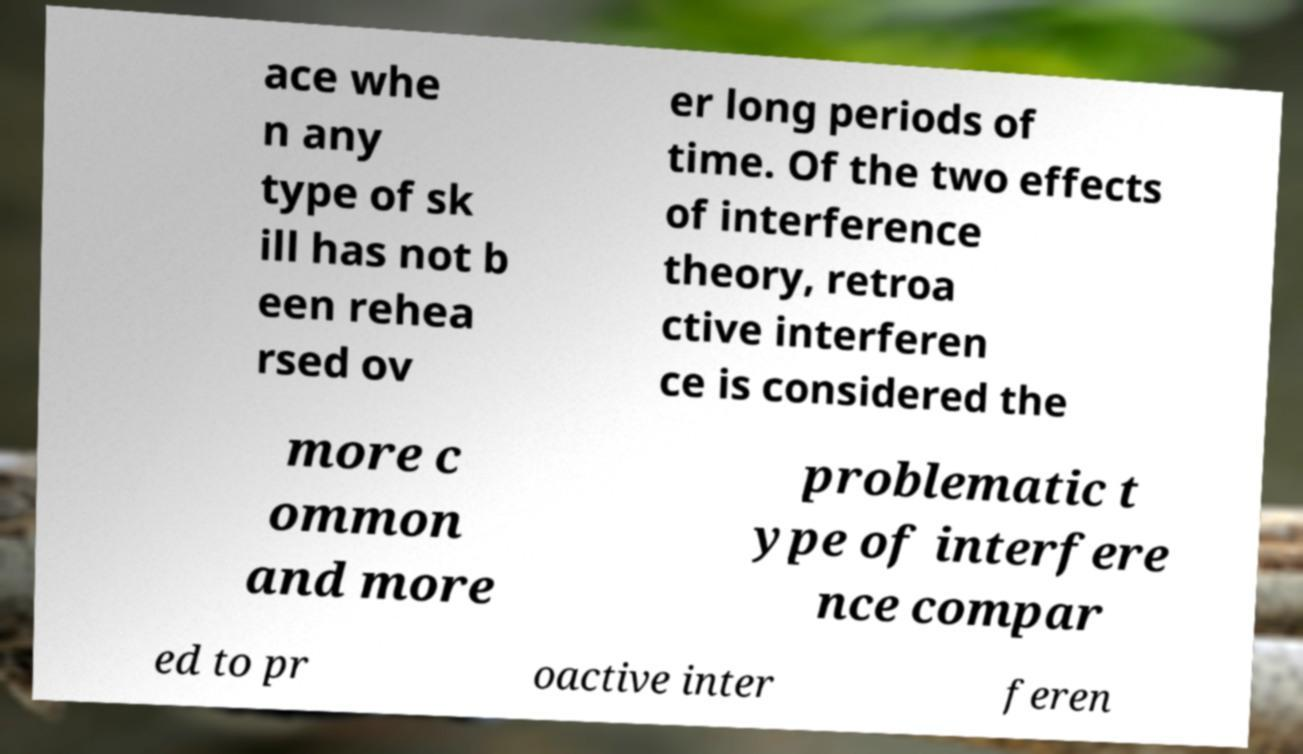There's text embedded in this image that I need extracted. Can you transcribe it verbatim? ace whe n any type of sk ill has not b een rehea rsed ov er long periods of time. Of the two effects of interference theory, retroa ctive interferen ce is considered the more c ommon and more problematic t ype of interfere nce compar ed to pr oactive inter feren 